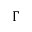<formula> <loc_0><loc_0><loc_500><loc_500>\Gamma</formula> 